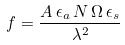Convert formula to latex. <formula><loc_0><loc_0><loc_500><loc_500>f = \frac { A \, \epsilon _ { a } \, N \, \Omega \, \epsilon _ { s } } { \lambda ^ { 2 } }</formula> 